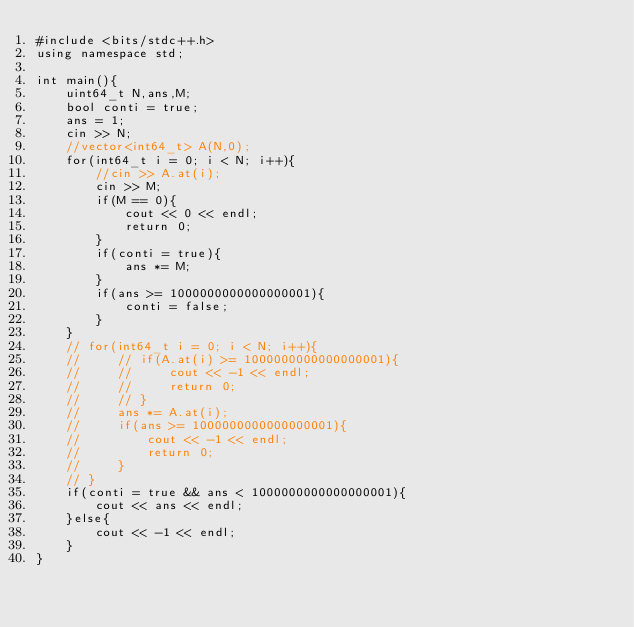Convert code to text. <code><loc_0><loc_0><loc_500><loc_500><_C++_>#include <bits/stdc++.h>
using namespace std;

int main(){
    uint64_t N,ans,M;
    bool conti = true;
    ans = 1;
    cin >> N;
    //vector<int64_t> A(N,0);
    for(int64_t i = 0; i < N; i++){
        //cin >> A.at(i);
        cin >> M;
        if(M == 0){
            cout << 0 << endl;
            return 0;
        }
        if(conti = true){
            ans *= M;
        }
        if(ans >= 1000000000000000001){
            conti = false;
        }
    }
    // for(int64_t i = 0; i < N; i++){
    //     // if(A.at(i) >= 1000000000000000001){
    //     //     cout << -1 << endl;
    //     //     return 0;
    //     // }
    //     ans *= A.at(i);
    //     if(ans >= 1000000000000000001){
    //         cout << -1 << endl;
    //         return 0;
    //     }
    // }
    if(conti = true && ans < 1000000000000000001){
        cout << ans << endl;
    }else{
        cout << -1 << endl;
    }
}
</code> 